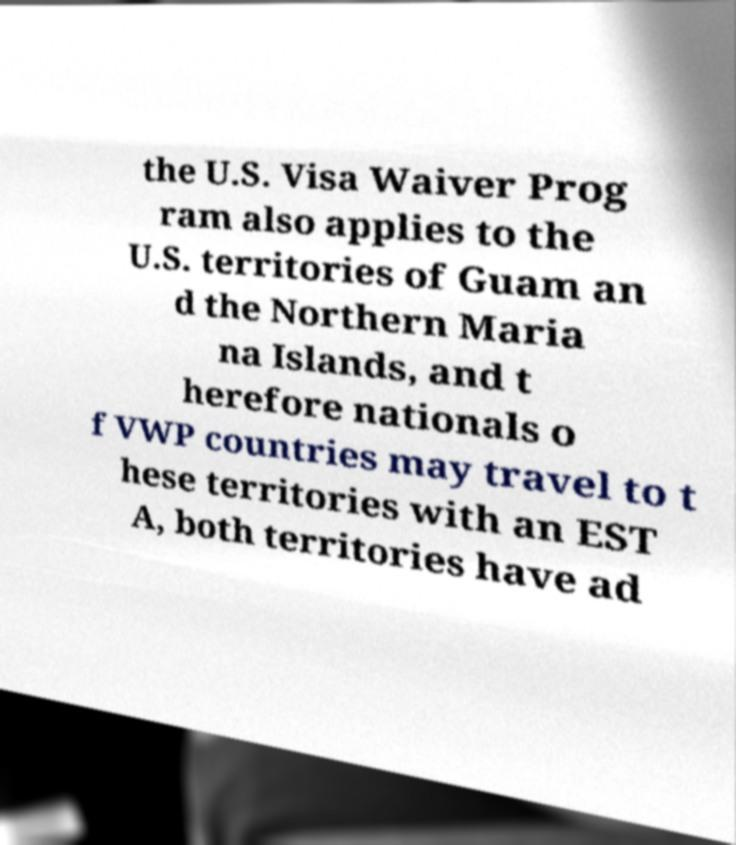Please read and relay the text visible in this image. What does it say? the U.S. Visa Waiver Prog ram also applies to the U.S. territories of Guam an d the Northern Maria na Islands, and t herefore nationals o f VWP countries may travel to t hese territories with an EST A, both territories have ad 